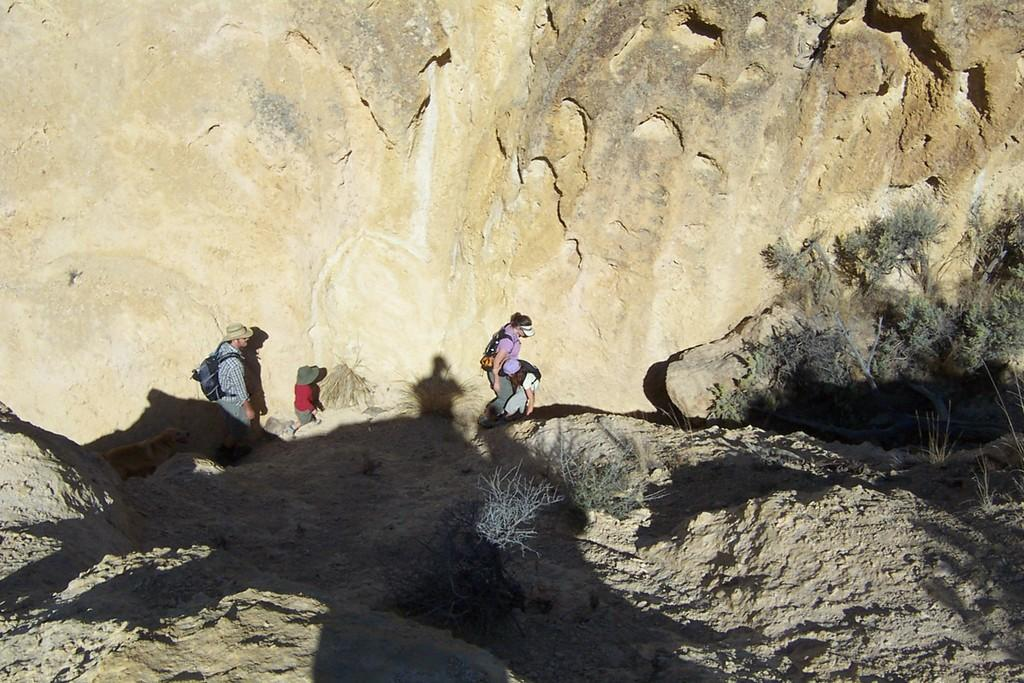How many people are in the image? There are four persons in the image. What are the persons doing in the image? The persons are climbing mountains. What type of terrain can be seen in the image? There are rocks visible in the image. What type of vegetation is present in the image? Small plants and trees are visible in the image. What type of feeling can be seen on the veins of the persons in the image? There is no indication of the persons' feelings or the visibility of their veins in the image. --- Facts: 1. There is a car in the image. 2. The car is parked on the street. 3. There are buildings in the background. 4. The sky is visible in the image. 5. There are trees on the side of the street. Absurd Topics: dance, ocean, volcano Conversation: What is the main subject of the image? The main subject of the image is a car. Where is the car located in the image? The car is parked on the street. What can be seen in the background of the image? There are buildings in the background. What is visible at the top of the image? The sky is visible in the image. What type of vegetation is present on the side of the street? There are trees on the side of the street. Reasoning: Let's think step by step in order to produce the conversation. We start by identifying the main subject of the image, which is the car. Then, we describe the car's location, which is parked on the street. Next, we mention the background and sky visible in the image, as well as the vegetation present on the side of the street. Each question is designed to elicit a specific detail about the image that is known from the provided facts. Absurd Question/Answer: Can you see any ocean or volcano in the image? No, there is no ocean or volcano present in the image. 